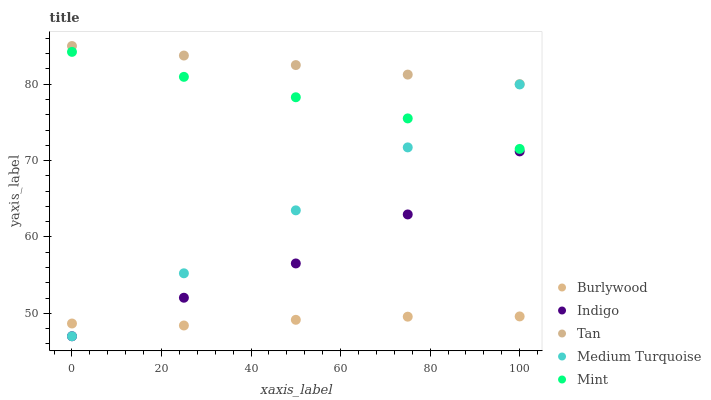Does Burlywood have the minimum area under the curve?
Answer yes or no. Yes. Does Tan have the maximum area under the curve?
Answer yes or no. Yes. Does Mint have the minimum area under the curve?
Answer yes or no. No. Does Mint have the maximum area under the curve?
Answer yes or no. No. Is Tan the smoothest?
Answer yes or no. Yes. Is Indigo the roughest?
Answer yes or no. Yes. Is Mint the smoothest?
Answer yes or no. No. Is Mint the roughest?
Answer yes or no. No. Does Indigo have the lowest value?
Answer yes or no. Yes. Does Mint have the lowest value?
Answer yes or no. No. Does Tan have the highest value?
Answer yes or no. Yes. Does Mint have the highest value?
Answer yes or no. No. Is Burlywood less than Tan?
Answer yes or no. Yes. Is Tan greater than Mint?
Answer yes or no. Yes. Does Medium Turquoise intersect Burlywood?
Answer yes or no. Yes. Is Medium Turquoise less than Burlywood?
Answer yes or no. No. Is Medium Turquoise greater than Burlywood?
Answer yes or no. No. Does Burlywood intersect Tan?
Answer yes or no. No. 